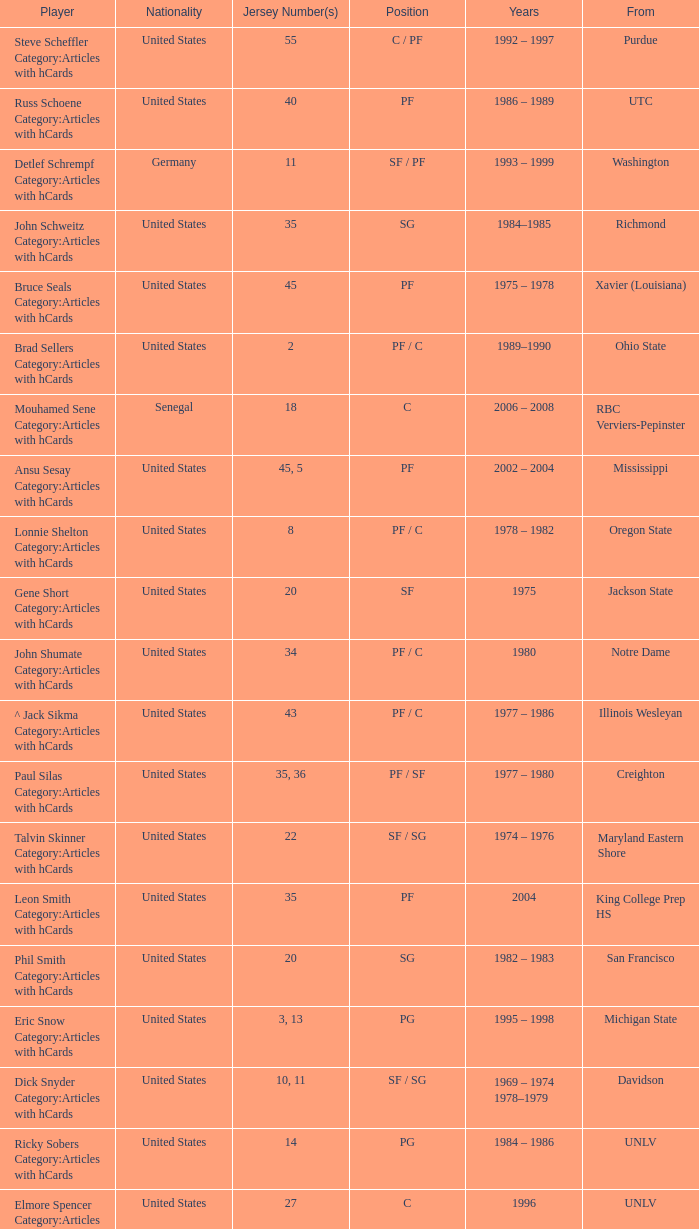Which spot does the participant with uniform number 22 occupy? SF / SG. 